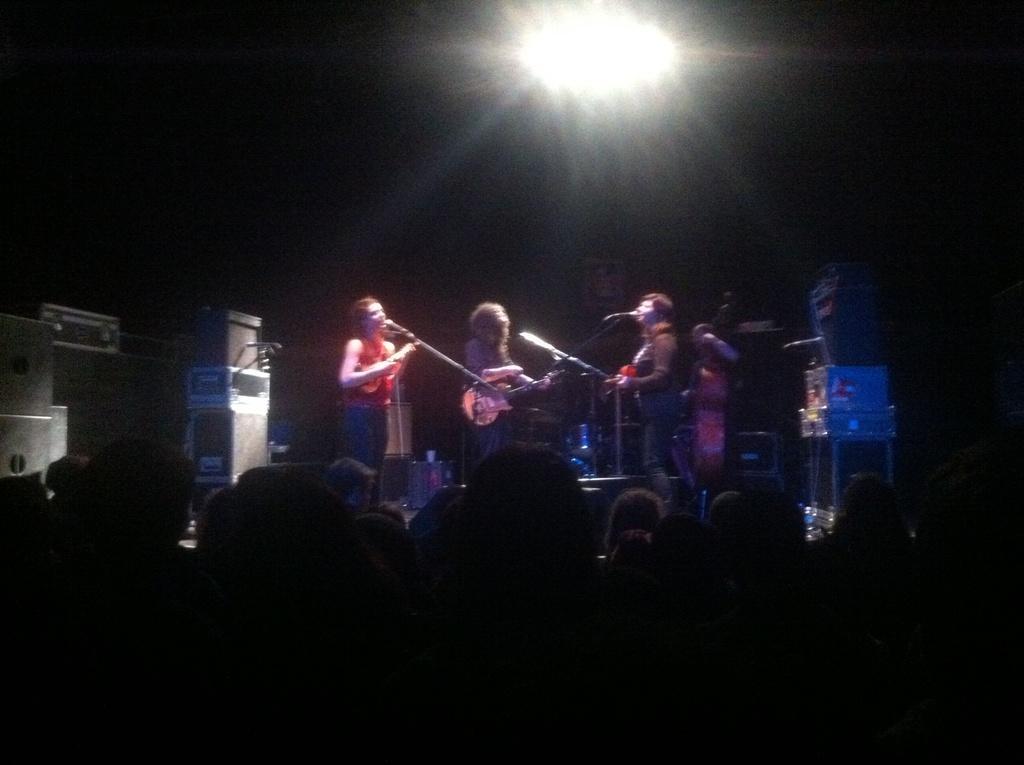Can you describe this image briefly? there are three people standing in front of a microphone with musical instrument in their hands there are some people standing in front of them and listening to them 